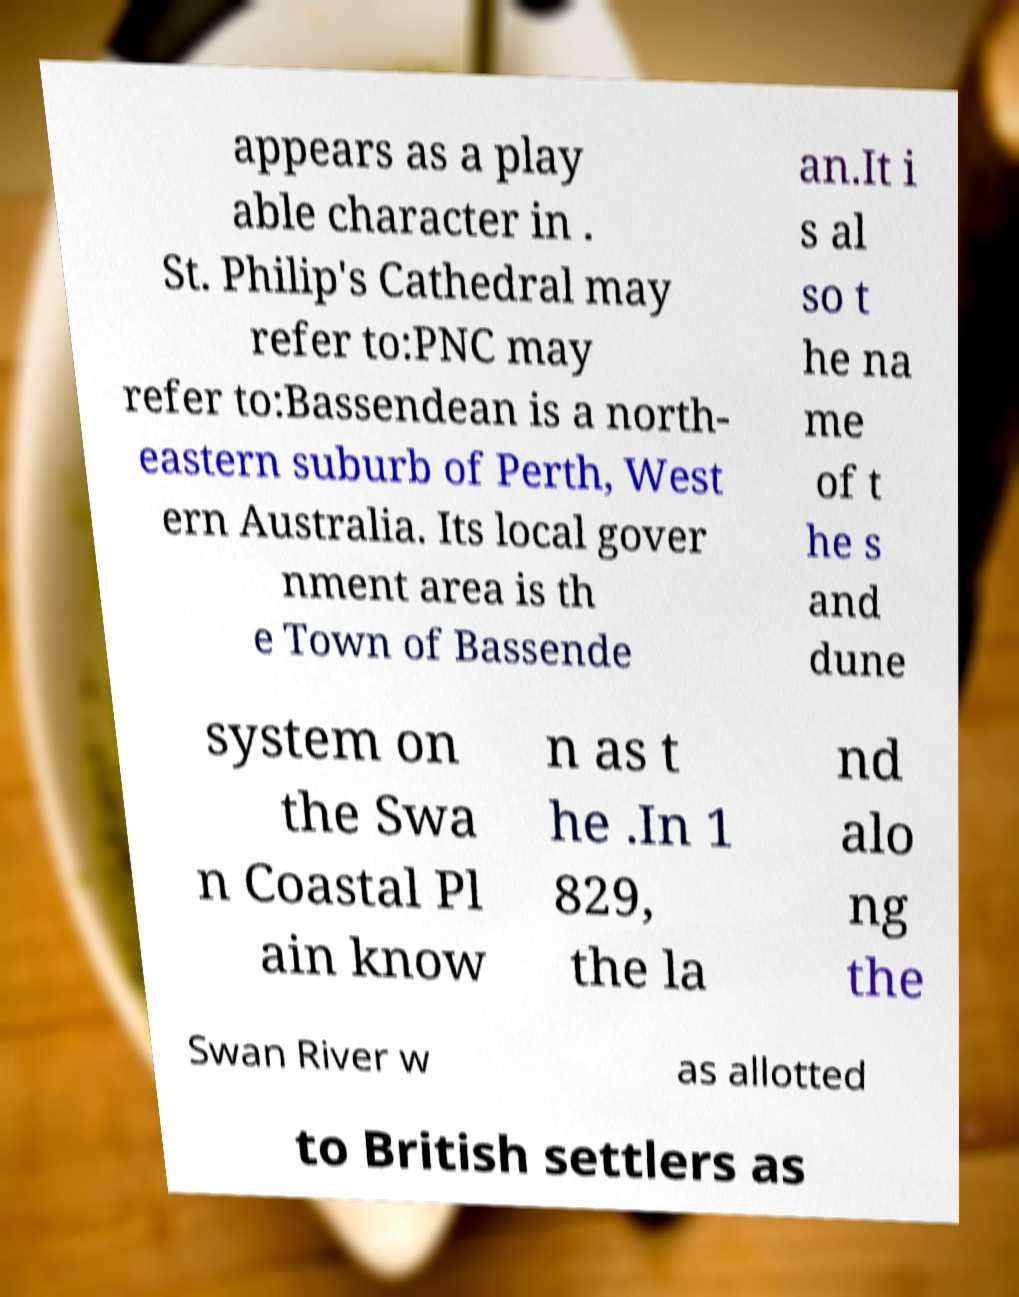For documentation purposes, I need the text within this image transcribed. Could you provide that? appears as a play able character in . St. Philip's Cathedral may refer to:PNC may refer to:Bassendean is a north- eastern suburb of Perth, West ern Australia. Its local gover nment area is th e Town of Bassende an.It i s al so t he na me of t he s and dune system on the Swa n Coastal Pl ain know n as t he .In 1 829, the la nd alo ng the Swan River w as allotted to British settlers as 